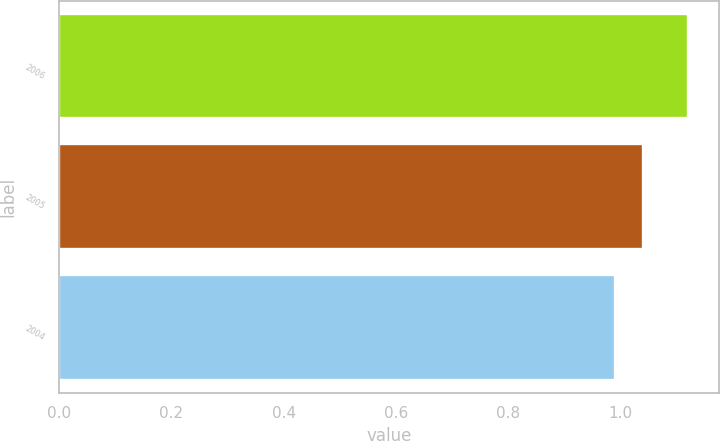Convert chart to OTSL. <chart><loc_0><loc_0><loc_500><loc_500><bar_chart><fcel>2006<fcel>2005<fcel>2004<nl><fcel>1.12<fcel>1.04<fcel>0.99<nl></chart> 